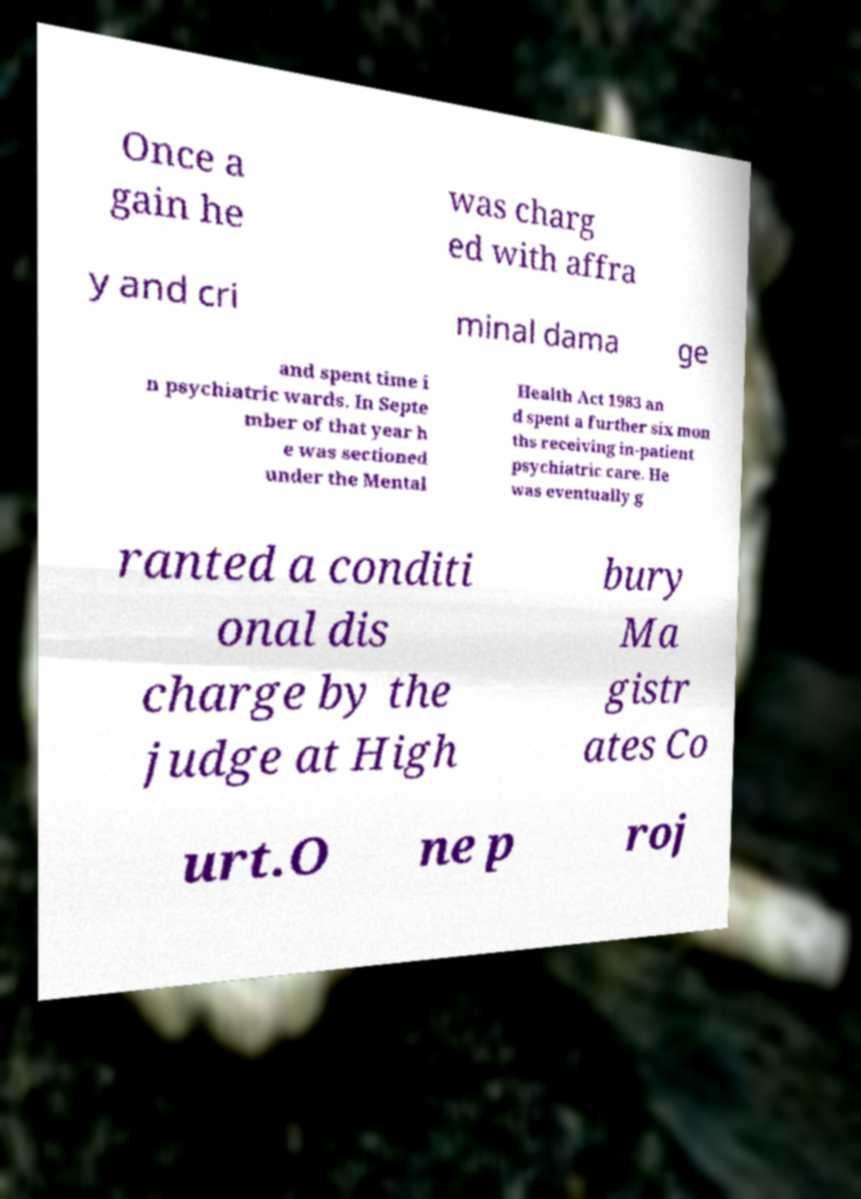I need the written content from this picture converted into text. Can you do that? Once a gain he was charg ed with affra y and cri minal dama ge and spent time i n psychiatric wards. In Septe mber of that year h e was sectioned under the Mental Health Act 1983 an d spent a further six mon ths receiving in-patient psychiatric care. He was eventually g ranted a conditi onal dis charge by the judge at High bury Ma gistr ates Co urt.O ne p roj 